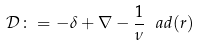Convert formula to latex. <formula><loc_0><loc_0><loc_500><loc_500>\mathcal { D } \colon = - \delta + \nabla - \frac { 1 } { \nu } \ a d ( r )</formula> 